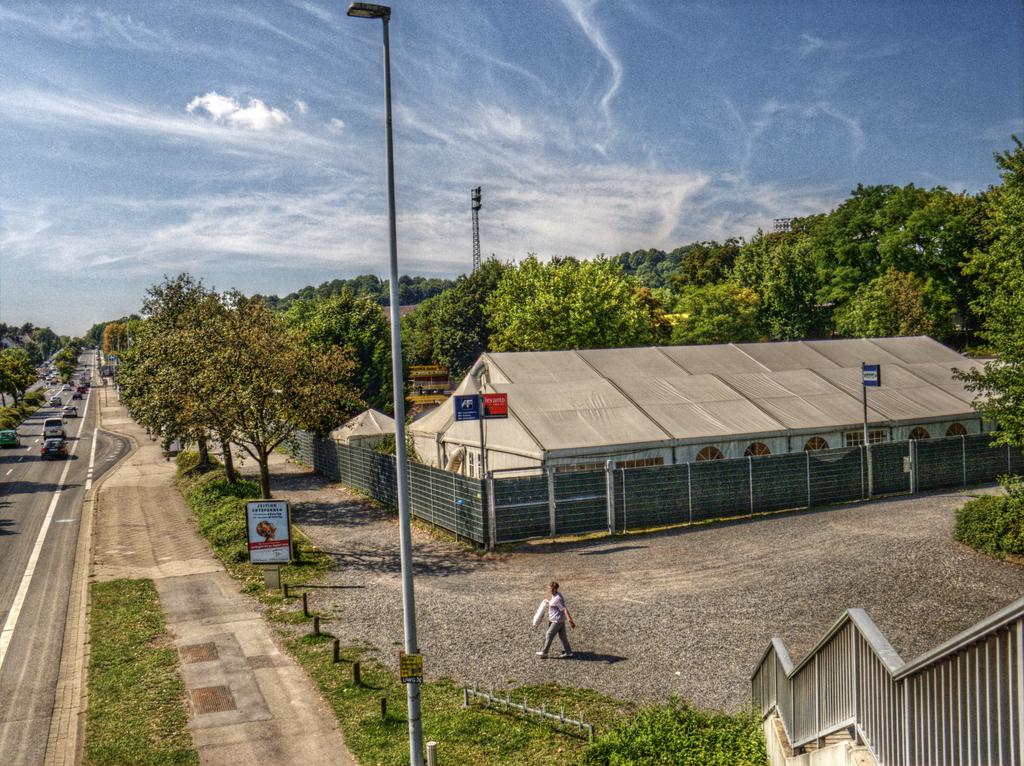What type of structure can be seen in the image? There is a building in the image. What is the person in the image doing? A person is walking on the ground in the image. What type of vegetation is present in the image? There are trees in the image. What are the poles used for in the image? The poles are not explicitly described in the facts, so we cannot determine their purpose. What type of ground surface is visible in the image? The grass is visible in the image. What type of barrier is present in the image? There is a fence in the image. What can be seen in the background of the image? Vehicles are present on the road and the sky is visible in the background of the image. What type of nut is being cracked by the person in the image? There is no nut present in the image; the person is walking on the ground. What day of the week is it in the image? The facts provided do not mention the day of the week, so we cannot determine the day. 